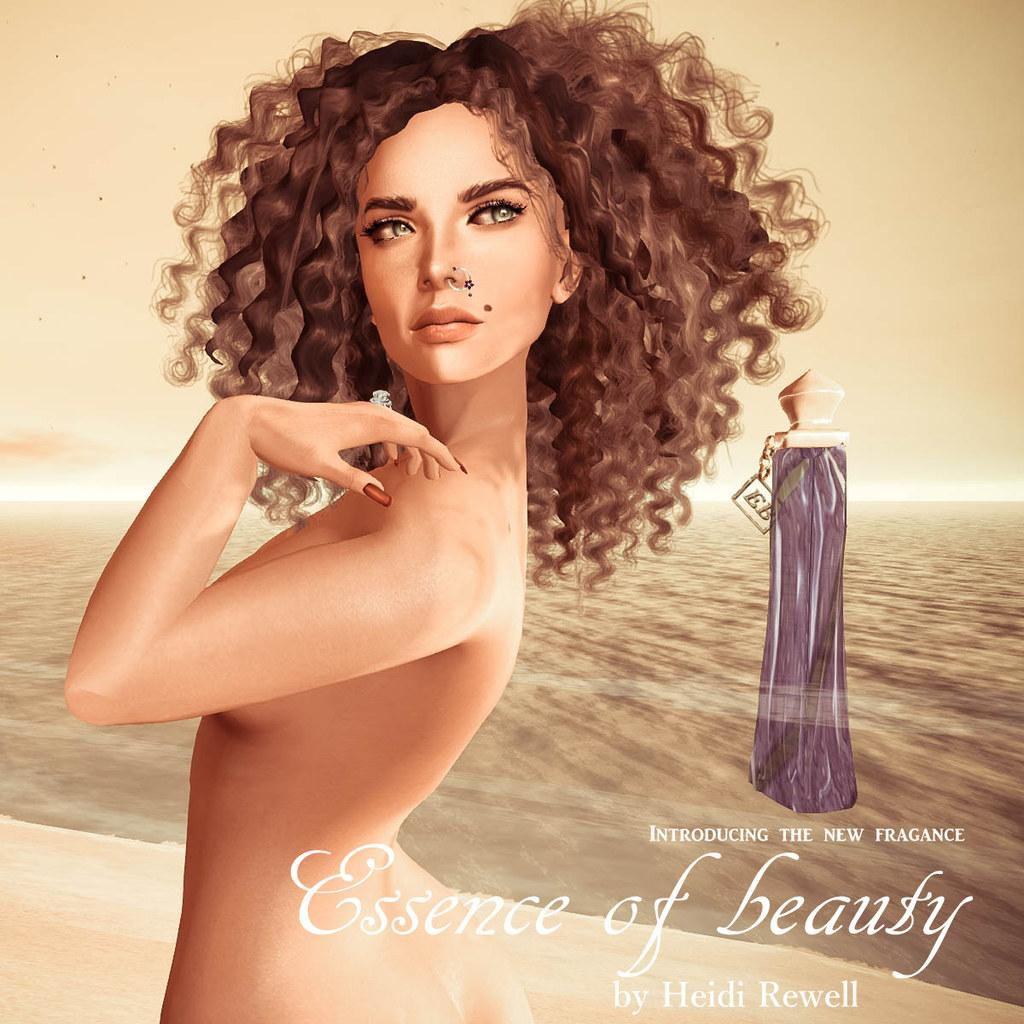<image>
Relay a brief, clear account of the picture shown. Advertisement showing a woman and the words "Essence of Beauty". 